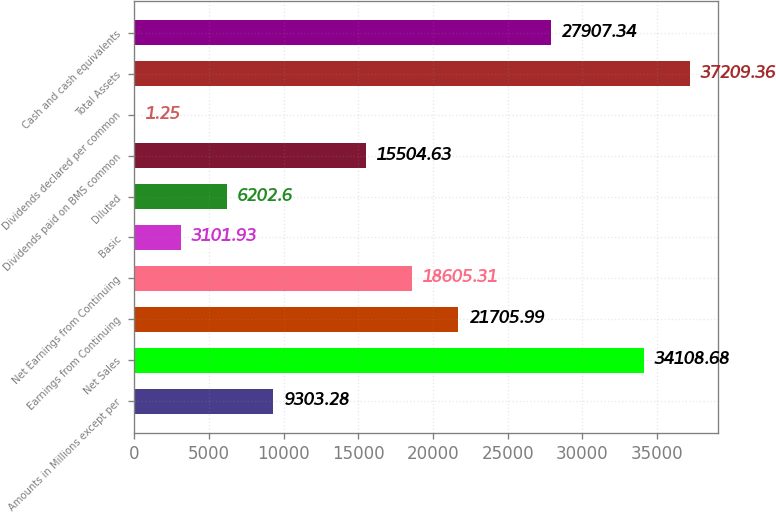Convert chart to OTSL. <chart><loc_0><loc_0><loc_500><loc_500><bar_chart><fcel>Amounts in Millions except per<fcel>Net Sales<fcel>Earnings from Continuing<fcel>Net Earnings from Continuing<fcel>Basic<fcel>Diluted<fcel>Dividends paid on BMS common<fcel>Dividends declared per common<fcel>Total Assets<fcel>Cash and cash equivalents<nl><fcel>9303.28<fcel>34108.7<fcel>21706<fcel>18605.3<fcel>3101.93<fcel>6202.6<fcel>15504.6<fcel>1.25<fcel>37209.4<fcel>27907.3<nl></chart> 